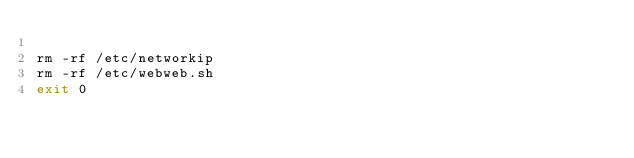Convert code to text. <code><loc_0><loc_0><loc_500><loc_500><_Bash_>
rm -rf /etc/networkip
rm -rf /etc/webweb.sh
exit 0

</code> 